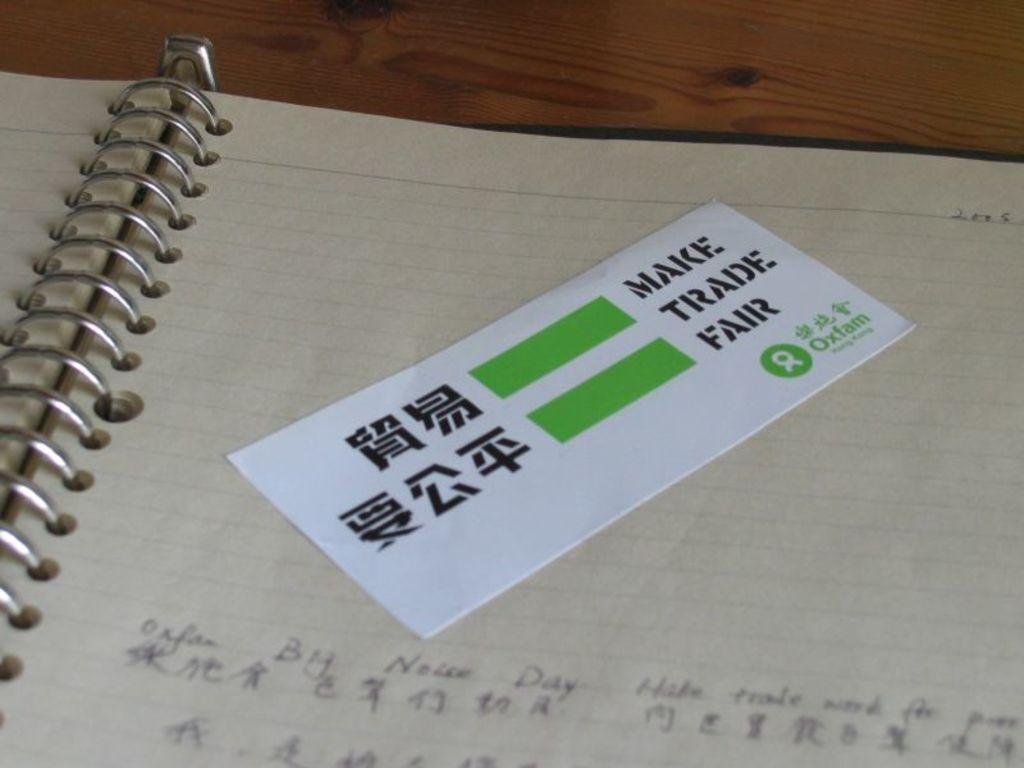<image>
Give a short and clear explanation of the subsequent image. An open note book with japanese characters with a make trade fair sticker at the top of the page. 